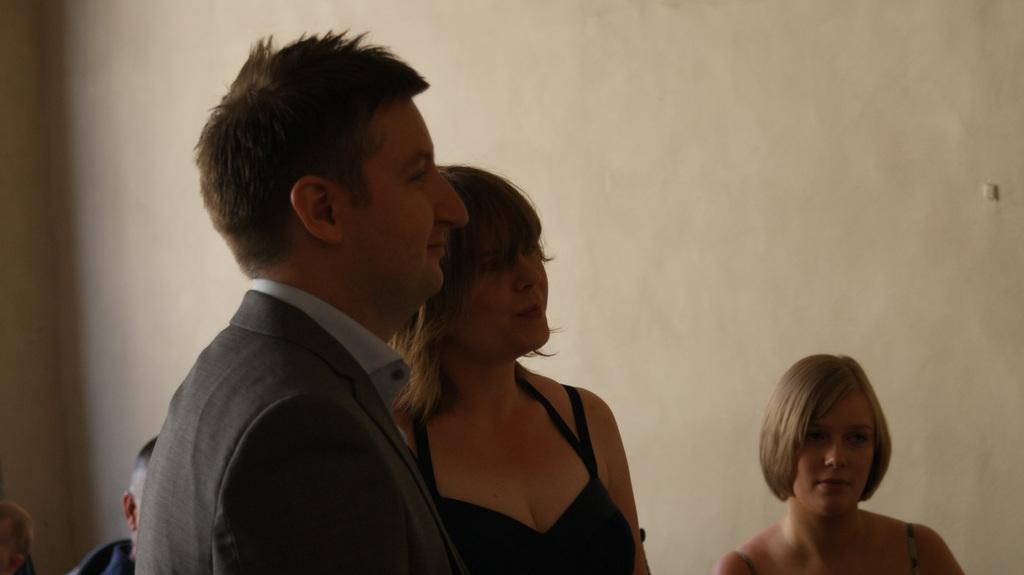What can be seen in the background of the image? The background of the image contains a wall painted with cream paint. How many women are in the image? There are two women in the image. Are there any men in the image? Yes, there is a man in the image. Can you describe the other person near the wall? There is another person near the wall, but their gender is not specified in the provided facts. What type of cow can be seen grazing near the wall in the image? There is no cow present in the image; the background contains a wall painted with cream paint, and there are people in the image. 